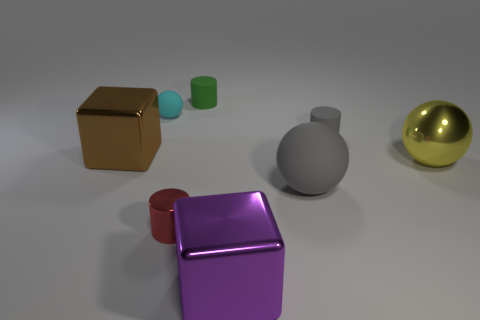Subtract all small red cylinders. How many cylinders are left? 2 Subtract 1 balls. How many balls are left? 2 Add 1 cylinders. How many objects exist? 9 Subtract all purple balls. Subtract all cyan blocks. How many balls are left? 3 Subtract all cylinders. How many objects are left? 5 Subtract 1 cyan balls. How many objects are left? 7 Subtract all gray cylinders. Subtract all tiny green matte objects. How many objects are left? 6 Add 5 blocks. How many blocks are left? 7 Add 3 gray rubber cylinders. How many gray rubber cylinders exist? 4 